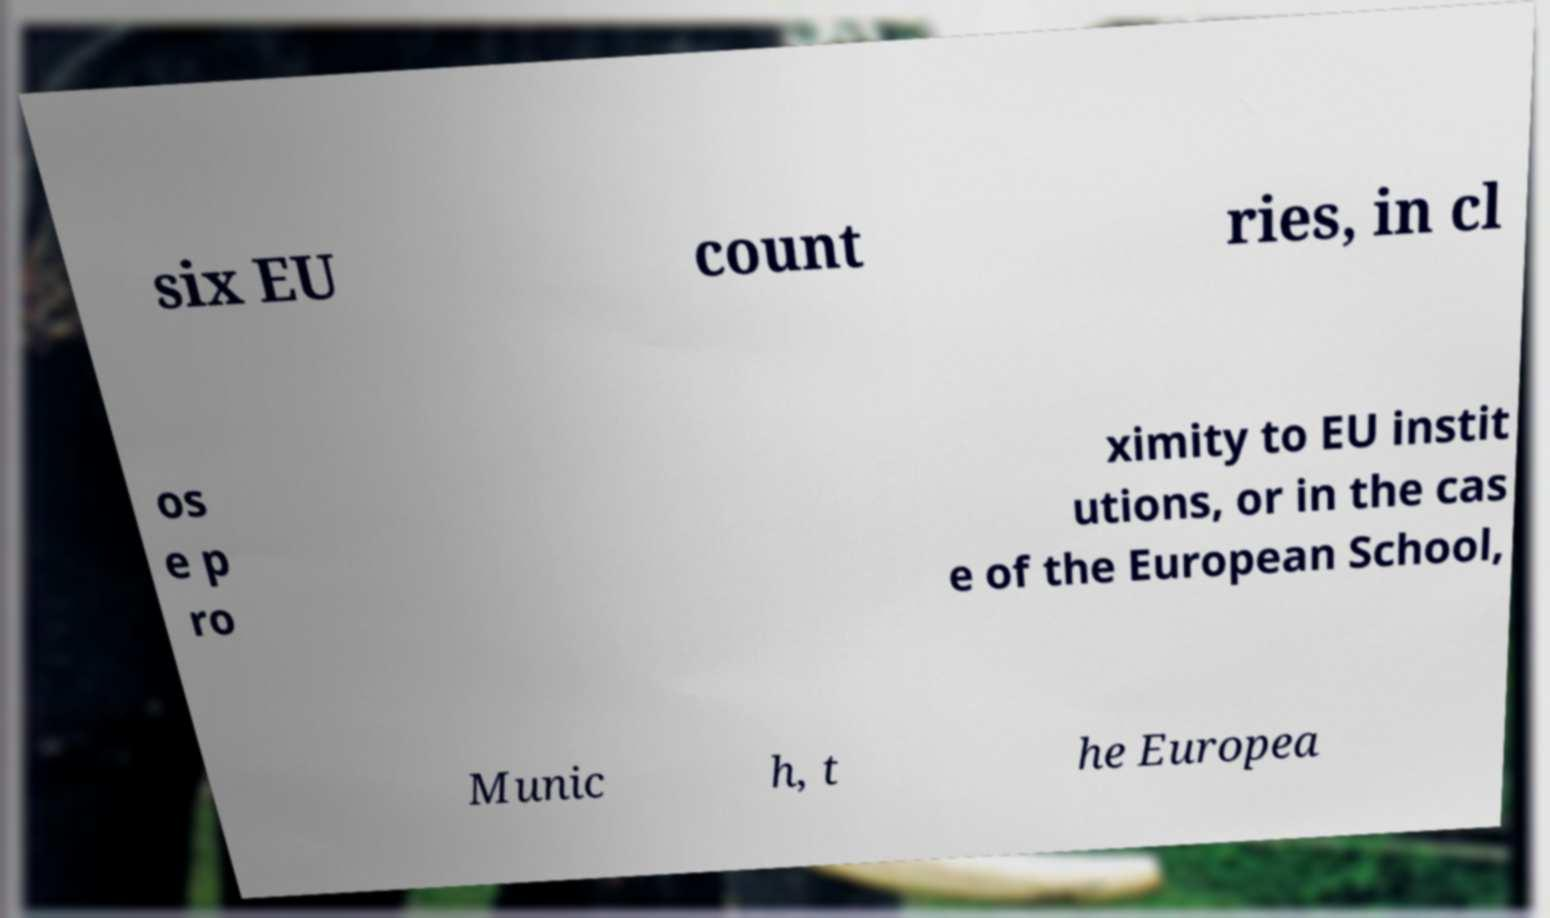For documentation purposes, I need the text within this image transcribed. Could you provide that? six EU count ries, in cl os e p ro ximity to EU instit utions, or in the cas e of the European School, Munic h, t he Europea 